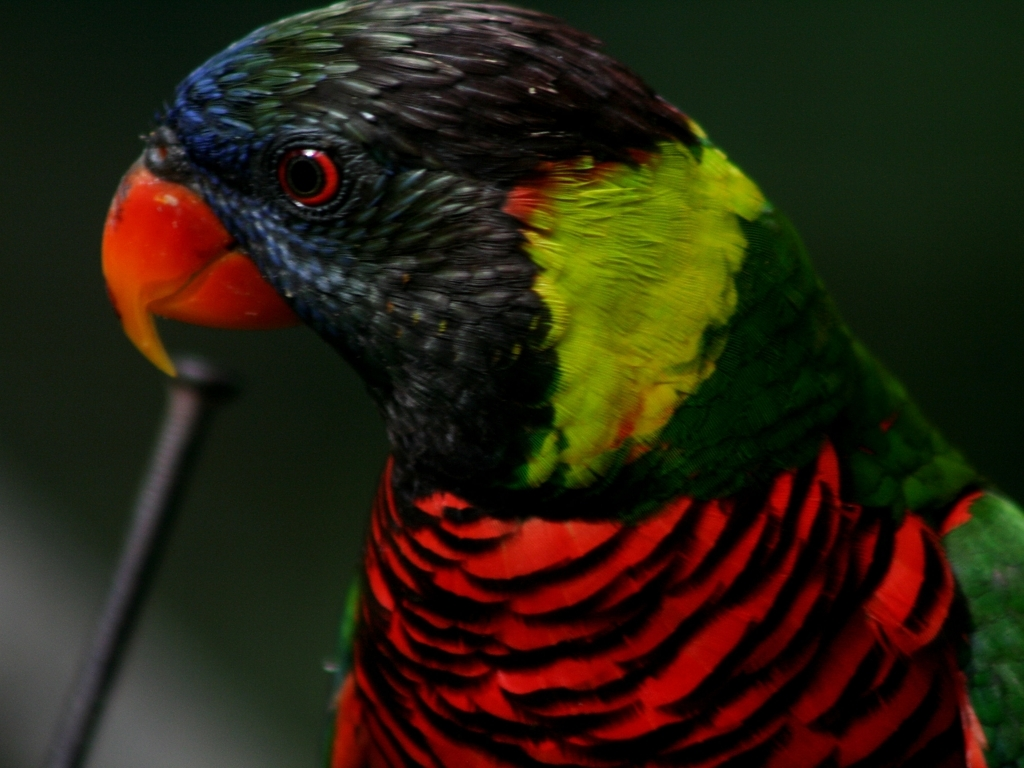What species of parrot is this, and can you tell me something interesting about it? This is a Rainbow Lorikeet. They are known for their vibrant plumage and their playful and chatty nature. Native to Australia, these birds are also important pollinators, often feeding on the nectar of various species of trees and flowering plants. 